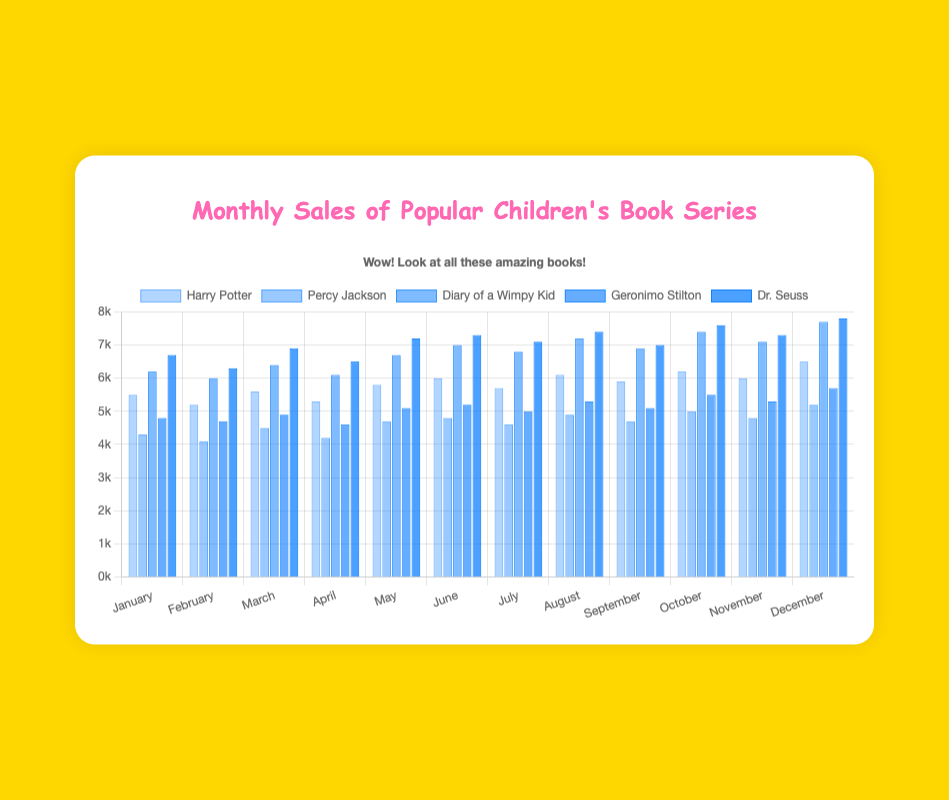Which book series had the highest sales in October? In October, the dataset shows sales for "Harry Potter", "Percy Jackson", "Diary of a Wimpy Kid", "Geronimo Stilton", and "Dr. Seuss". By checking the figure, "Dr. Seuss" has the highest bar, indicating the highest sales.
Answer: Dr. Seuss What is the difference in sales between "Harry Potter" and "Percy Jackson" in August? In August, the sales for "Harry Potter" are 6100 and for "Percy Jackson" are 4900. The difference can be calculated as 6100 - 4900 = 1200.
Answer: 1200 Which month had the lowest sales for "Diary of a Wimpy Kid"? By looking at the bars for "Diary of a Wimpy Kid" across all months, February has the shortest bar, indicating the lowest sales.
Answer: February What is the average monthly sales of "Geronimo Stilton" in the first quarter (January to March)? January sales: 4800, February sales: 4700, March sales: 4900. Sum = 4800 + 4700 + 4900 = 14400. Average = 14400 / 3 = 4800.
Answer: 4800 In June, which book series had higher sales, "Harry Potter" or "Diary of a Wimpy Kid"? For June, the sales for "Harry Potter" are 6000 and for "Diary of a Wimpy Kid" are 7000. Comparing the two, "Diary of a Wimpy Kid" had higher sales.
Answer: Diary of a Wimpy Kid Which book series had the most consistent (least variable) sales across the year? By comparing the bars' heights for each book series across different months, "Geronimo Stilton" shows the least variation in its bar heights, indicating consistent sales.
Answer: Geronimo Stilton What was the total sales for "Dr. Seuss" in the second half of the year (July to December)? Adding the sales from July to December for "Dr. Seuss": 7100 + 7400 + 7000 + 7600 + 7300 + 7800 = 44200.
Answer: 44200 Which month saw the highest cumulative sales for all book series combined? Summing up the sales for all series each month, December has the highest cumulative sales. By visual inspection, December shows the tallest combined height of bars.
Answer: December 